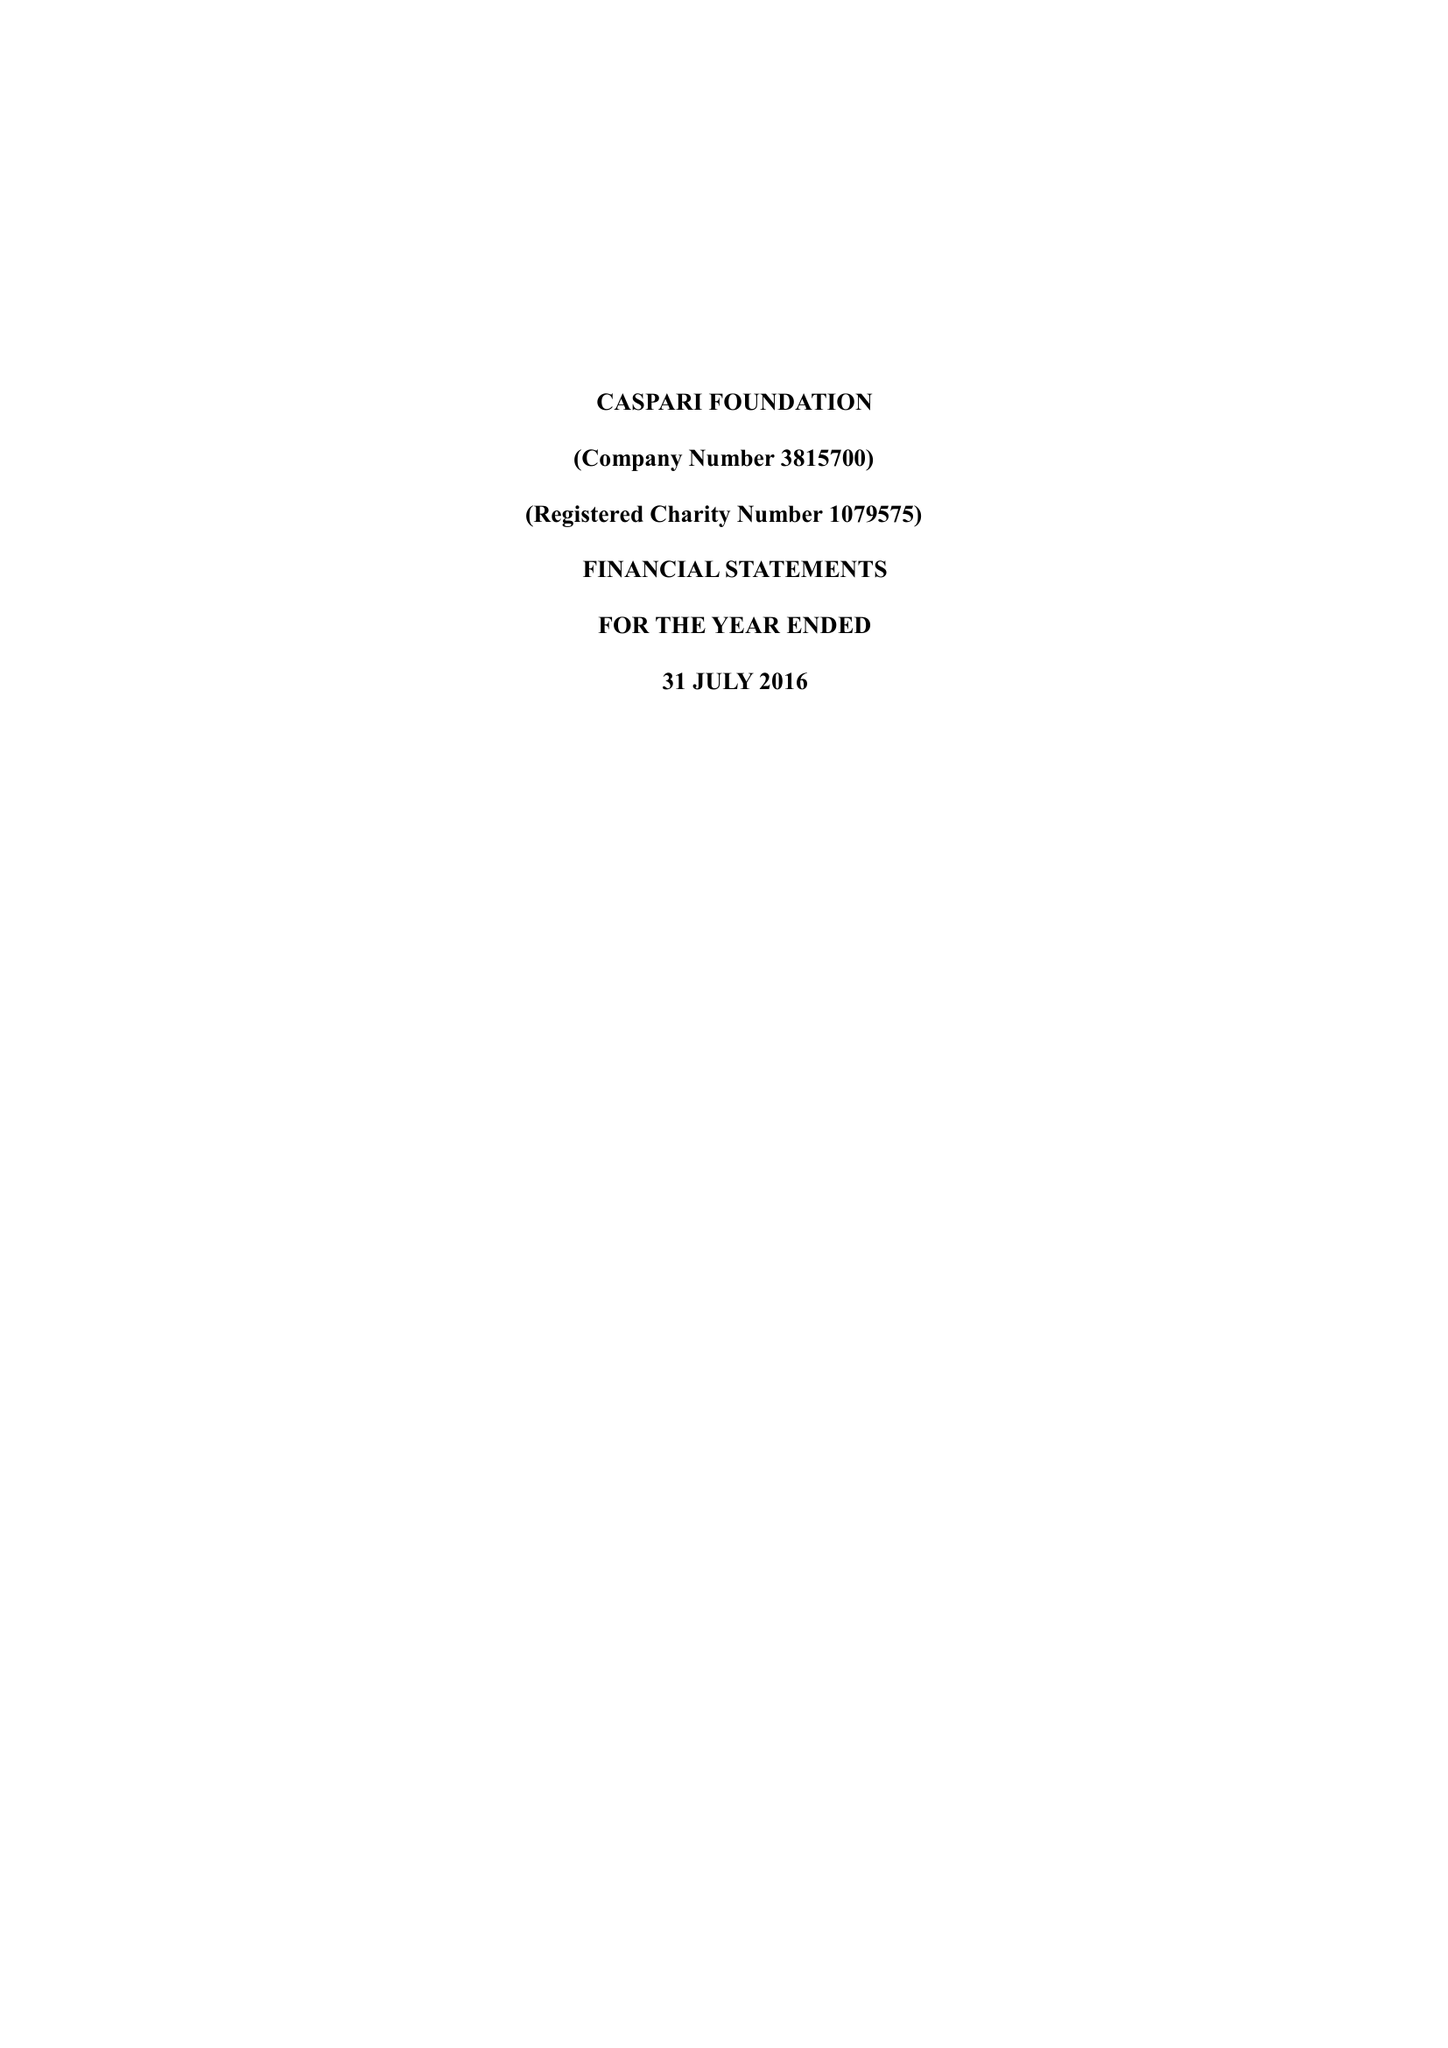What is the value for the address__street_line?
Answer the question using a single word or phrase. 225-229 SEVEN SISTERS ROAD 